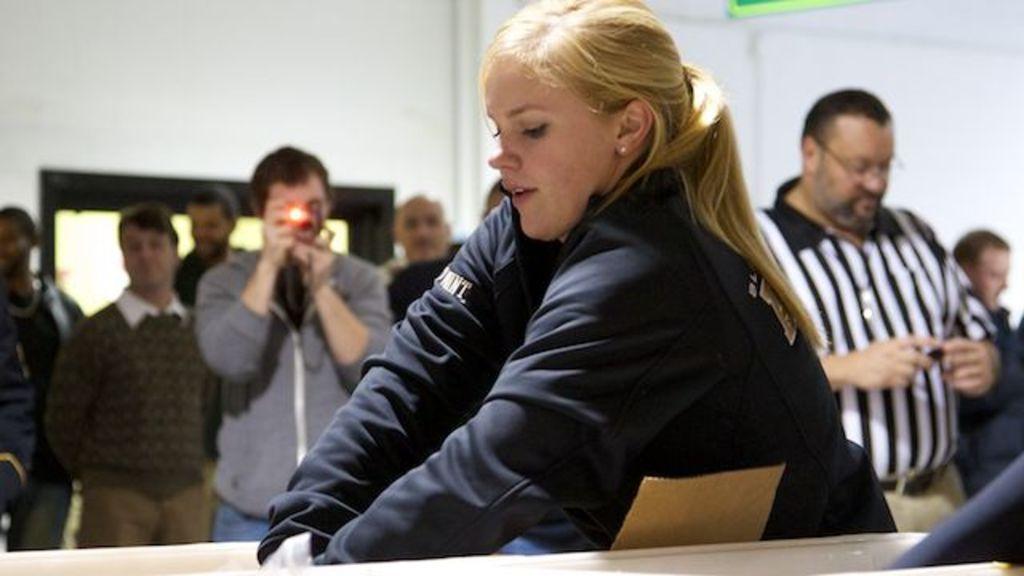Can you describe this image briefly? In the image we can see a woman wearing clothes and ear studs. Around there are other people standing, wearing clothes and there is the person holding camera in hand and the wall. 